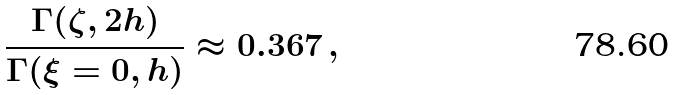Convert formula to latex. <formula><loc_0><loc_0><loc_500><loc_500>\frac { \Gamma ( \zeta , 2 h ) } { \Gamma ( \xi = 0 , h ) } \approx 0 . 3 6 7 \, ,</formula> 